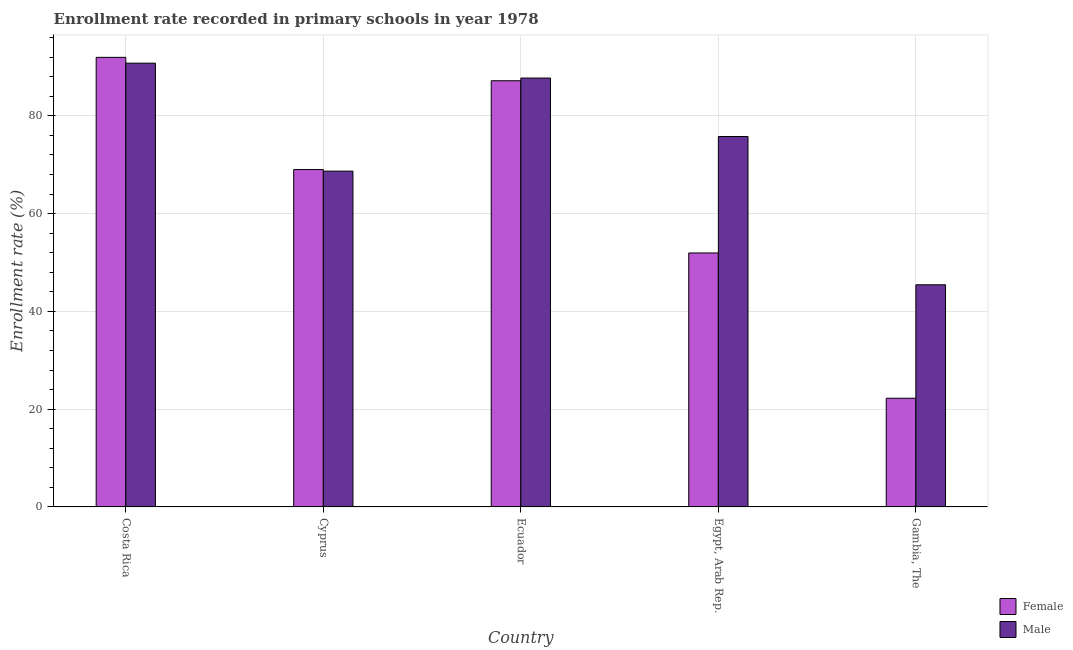Are the number of bars per tick equal to the number of legend labels?
Offer a terse response. Yes. Are the number of bars on each tick of the X-axis equal?
Ensure brevity in your answer.  Yes. How many bars are there on the 2nd tick from the left?
Give a very brief answer. 2. How many bars are there on the 5th tick from the right?
Make the answer very short. 2. What is the label of the 4th group of bars from the left?
Provide a succinct answer. Egypt, Arab Rep. In how many cases, is the number of bars for a given country not equal to the number of legend labels?
Your answer should be very brief. 0. What is the enrollment rate of female students in Egypt, Arab Rep.?
Give a very brief answer. 51.96. Across all countries, what is the maximum enrollment rate of female students?
Make the answer very short. 91.98. Across all countries, what is the minimum enrollment rate of female students?
Make the answer very short. 22.24. In which country was the enrollment rate of male students minimum?
Your answer should be compact. Gambia, The. What is the total enrollment rate of male students in the graph?
Provide a succinct answer. 368.46. What is the difference between the enrollment rate of female students in Costa Rica and that in Gambia, The?
Your response must be concise. 69.74. What is the difference between the enrollment rate of male students in Gambia, The and the enrollment rate of female students in Egypt, Arab Rep.?
Provide a succinct answer. -6.51. What is the average enrollment rate of male students per country?
Offer a terse response. 73.69. What is the difference between the enrollment rate of female students and enrollment rate of male students in Gambia, The?
Offer a very short reply. -23.21. What is the ratio of the enrollment rate of male students in Costa Rica to that in Cyprus?
Your answer should be compact. 1.32. What is the difference between the highest and the second highest enrollment rate of female students?
Your answer should be very brief. 4.78. What is the difference between the highest and the lowest enrollment rate of male students?
Offer a very short reply. 45.34. What does the 1st bar from the left in Egypt, Arab Rep. represents?
Keep it short and to the point. Female. What is the difference between two consecutive major ticks on the Y-axis?
Offer a very short reply. 20. Does the graph contain any zero values?
Your answer should be compact. No. Where does the legend appear in the graph?
Give a very brief answer. Bottom right. How are the legend labels stacked?
Make the answer very short. Vertical. What is the title of the graph?
Provide a succinct answer. Enrollment rate recorded in primary schools in year 1978. Does "Transport services" appear as one of the legend labels in the graph?
Provide a succinct answer. No. What is the label or title of the Y-axis?
Your answer should be very brief. Enrollment rate (%). What is the Enrollment rate (%) of Female in Costa Rica?
Your response must be concise. 91.98. What is the Enrollment rate (%) in Male in Costa Rica?
Your answer should be very brief. 90.79. What is the Enrollment rate (%) of Female in Cyprus?
Keep it short and to the point. 69.02. What is the Enrollment rate (%) in Male in Cyprus?
Provide a succinct answer. 68.7. What is the Enrollment rate (%) of Female in Ecuador?
Offer a terse response. 87.19. What is the Enrollment rate (%) of Male in Ecuador?
Give a very brief answer. 87.74. What is the Enrollment rate (%) in Female in Egypt, Arab Rep.?
Give a very brief answer. 51.96. What is the Enrollment rate (%) in Male in Egypt, Arab Rep.?
Your response must be concise. 75.78. What is the Enrollment rate (%) of Female in Gambia, The?
Offer a very short reply. 22.24. What is the Enrollment rate (%) in Male in Gambia, The?
Offer a very short reply. 45.45. Across all countries, what is the maximum Enrollment rate (%) of Female?
Your response must be concise. 91.98. Across all countries, what is the maximum Enrollment rate (%) of Male?
Offer a very short reply. 90.79. Across all countries, what is the minimum Enrollment rate (%) of Female?
Keep it short and to the point. 22.24. Across all countries, what is the minimum Enrollment rate (%) of Male?
Your response must be concise. 45.45. What is the total Enrollment rate (%) in Female in the graph?
Give a very brief answer. 322.38. What is the total Enrollment rate (%) in Male in the graph?
Provide a short and direct response. 368.45. What is the difference between the Enrollment rate (%) of Female in Costa Rica and that in Cyprus?
Make the answer very short. 22.96. What is the difference between the Enrollment rate (%) in Male in Costa Rica and that in Cyprus?
Offer a terse response. 22.09. What is the difference between the Enrollment rate (%) in Female in Costa Rica and that in Ecuador?
Keep it short and to the point. 4.78. What is the difference between the Enrollment rate (%) of Male in Costa Rica and that in Ecuador?
Make the answer very short. 3.04. What is the difference between the Enrollment rate (%) in Female in Costa Rica and that in Egypt, Arab Rep.?
Provide a short and direct response. 40.02. What is the difference between the Enrollment rate (%) of Male in Costa Rica and that in Egypt, Arab Rep.?
Your response must be concise. 15. What is the difference between the Enrollment rate (%) of Female in Costa Rica and that in Gambia, The?
Offer a terse response. 69.74. What is the difference between the Enrollment rate (%) in Male in Costa Rica and that in Gambia, The?
Your response must be concise. 45.34. What is the difference between the Enrollment rate (%) in Female in Cyprus and that in Ecuador?
Provide a succinct answer. -18.17. What is the difference between the Enrollment rate (%) of Male in Cyprus and that in Ecuador?
Make the answer very short. -19.05. What is the difference between the Enrollment rate (%) of Female in Cyprus and that in Egypt, Arab Rep.?
Ensure brevity in your answer.  17.06. What is the difference between the Enrollment rate (%) of Male in Cyprus and that in Egypt, Arab Rep.?
Give a very brief answer. -7.08. What is the difference between the Enrollment rate (%) in Female in Cyprus and that in Gambia, The?
Give a very brief answer. 46.78. What is the difference between the Enrollment rate (%) of Male in Cyprus and that in Gambia, The?
Provide a succinct answer. 23.25. What is the difference between the Enrollment rate (%) in Female in Ecuador and that in Egypt, Arab Rep.?
Your response must be concise. 35.23. What is the difference between the Enrollment rate (%) of Male in Ecuador and that in Egypt, Arab Rep.?
Your response must be concise. 11.96. What is the difference between the Enrollment rate (%) in Female in Ecuador and that in Gambia, The?
Your response must be concise. 64.95. What is the difference between the Enrollment rate (%) in Male in Ecuador and that in Gambia, The?
Provide a succinct answer. 42.29. What is the difference between the Enrollment rate (%) of Female in Egypt, Arab Rep. and that in Gambia, The?
Your answer should be very brief. 29.72. What is the difference between the Enrollment rate (%) in Male in Egypt, Arab Rep. and that in Gambia, The?
Your answer should be very brief. 30.33. What is the difference between the Enrollment rate (%) of Female in Costa Rica and the Enrollment rate (%) of Male in Cyprus?
Ensure brevity in your answer.  23.28. What is the difference between the Enrollment rate (%) of Female in Costa Rica and the Enrollment rate (%) of Male in Ecuador?
Offer a very short reply. 4.23. What is the difference between the Enrollment rate (%) in Female in Costa Rica and the Enrollment rate (%) in Male in Egypt, Arab Rep.?
Give a very brief answer. 16.19. What is the difference between the Enrollment rate (%) of Female in Costa Rica and the Enrollment rate (%) of Male in Gambia, The?
Keep it short and to the point. 46.53. What is the difference between the Enrollment rate (%) of Female in Cyprus and the Enrollment rate (%) of Male in Ecuador?
Make the answer very short. -18.72. What is the difference between the Enrollment rate (%) in Female in Cyprus and the Enrollment rate (%) in Male in Egypt, Arab Rep.?
Your answer should be very brief. -6.76. What is the difference between the Enrollment rate (%) of Female in Cyprus and the Enrollment rate (%) of Male in Gambia, The?
Make the answer very short. 23.57. What is the difference between the Enrollment rate (%) of Female in Ecuador and the Enrollment rate (%) of Male in Egypt, Arab Rep.?
Provide a succinct answer. 11.41. What is the difference between the Enrollment rate (%) in Female in Ecuador and the Enrollment rate (%) in Male in Gambia, The?
Offer a terse response. 41.74. What is the difference between the Enrollment rate (%) in Female in Egypt, Arab Rep. and the Enrollment rate (%) in Male in Gambia, The?
Give a very brief answer. 6.51. What is the average Enrollment rate (%) in Female per country?
Provide a short and direct response. 64.48. What is the average Enrollment rate (%) of Male per country?
Ensure brevity in your answer.  73.69. What is the difference between the Enrollment rate (%) in Female and Enrollment rate (%) in Male in Costa Rica?
Your answer should be very brief. 1.19. What is the difference between the Enrollment rate (%) in Female and Enrollment rate (%) in Male in Cyprus?
Provide a succinct answer. 0.32. What is the difference between the Enrollment rate (%) of Female and Enrollment rate (%) of Male in Ecuador?
Ensure brevity in your answer.  -0.55. What is the difference between the Enrollment rate (%) of Female and Enrollment rate (%) of Male in Egypt, Arab Rep.?
Offer a terse response. -23.82. What is the difference between the Enrollment rate (%) of Female and Enrollment rate (%) of Male in Gambia, The?
Offer a very short reply. -23.21. What is the ratio of the Enrollment rate (%) in Female in Costa Rica to that in Cyprus?
Your answer should be compact. 1.33. What is the ratio of the Enrollment rate (%) of Male in Costa Rica to that in Cyprus?
Offer a very short reply. 1.32. What is the ratio of the Enrollment rate (%) of Female in Costa Rica to that in Ecuador?
Your response must be concise. 1.05. What is the ratio of the Enrollment rate (%) of Male in Costa Rica to that in Ecuador?
Offer a terse response. 1.03. What is the ratio of the Enrollment rate (%) in Female in Costa Rica to that in Egypt, Arab Rep.?
Offer a very short reply. 1.77. What is the ratio of the Enrollment rate (%) in Male in Costa Rica to that in Egypt, Arab Rep.?
Your response must be concise. 1.2. What is the ratio of the Enrollment rate (%) in Female in Costa Rica to that in Gambia, The?
Provide a short and direct response. 4.14. What is the ratio of the Enrollment rate (%) in Male in Costa Rica to that in Gambia, The?
Keep it short and to the point. 2. What is the ratio of the Enrollment rate (%) of Female in Cyprus to that in Ecuador?
Your answer should be very brief. 0.79. What is the ratio of the Enrollment rate (%) in Male in Cyprus to that in Ecuador?
Give a very brief answer. 0.78. What is the ratio of the Enrollment rate (%) in Female in Cyprus to that in Egypt, Arab Rep.?
Keep it short and to the point. 1.33. What is the ratio of the Enrollment rate (%) in Male in Cyprus to that in Egypt, Arab Rep.?
Offer a terse response. 0.91. What is the ratio of the Enrollment rate (%) of Female in Cyprus to that in Gambia, The?
Offer a terse response. 3.1. What is the ratio of the Enrollment rate (%) of Male in Cyprus to that in Gambia, The?
Provide a short and direct response. 1.51. What is the ratio of the Enrollment rate (%) in Female in Ecuador to that in Egypt, Arab Rep.?
Your response must be concise. 1.68. What is the ratio of the Enrollment rate (%) of Male in Ecuador to that in Egypt, Arab Rep.?
Your answer should be compact. 1.16. What is the ratio of the Enrollment rate (%) in Female in Ecuador to that in Gambia, The?
Provide a succinct answer. 3.92. What is the ratio of the Enrollment rate (%) of Male in Ecuador to that in Gambia, The?
Ensure brevity in your answer.  1.93. What is the ratio of the Enrollment rate (%) in Female in Egypt, Arab Rep. to that in Gambia, The?
Provide a succinct answer. 2.34. What is the ratio of the Enrollment rate (%) in Male in Egypt, Arab Rep. to that in Gambia, The?
Ensure brevity in your answer.  1.67. What is the difference between the highest and the second highest Enrollment rate (%) in Female?
Offer a very short reply. 4.78. What is the difference between the highest and the second highest Enrollment rate (%) in Male?
Keep it short and to the point. 3.04. What is the difference between the highest and the lowest Enrollment rate (%) in Female?
Offer a very short reply. 69.74. What is the difference between the highest and the lowest Enrollment rate (%) of Male?
Provide a short and direct response. 45.34. 